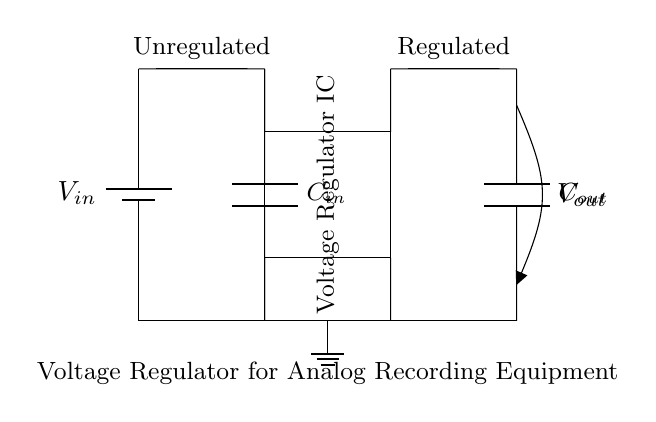What is the input voltage labeled as? The input voltage in the circuit is labeled as V in, which indicates the source voltage coming into the circuit for regulation.
Answer: V in What is the purpose of the voltage regulator IC? The voltage regulator IC's purpose is to stabilize and regulate the voltage output from the varying input level, ensuring consistent performance for connected analog recording equipment.
Answer: Stabilizes voltage How many capacitors are present in the circuit? There are two capacitors in the circuit: the input capacitor labeled as C in and the output capacitor labeled as C out, used for filtering.
Answer: Two What type of circuit is depicted in the diagram? This circuit is a voltage regulator circuit, which is specifically used to provide a controlled output voltage from an unregulated input voltage supply.
Answer: Voltage regulator circuit What is the output voltage connected to in this circuit? The output voltage labeled as V out connects to the final output of the circuit where the regulated power supply is provided to the analog recording equipment.
Answer: V out Why are there ground connections in the circuit? Ground connections are essential for establishing a common reference point in the circuit, ensuring that all voltage measurements and circuit operations are based on the same reference level.
Answer: To provide a reference 